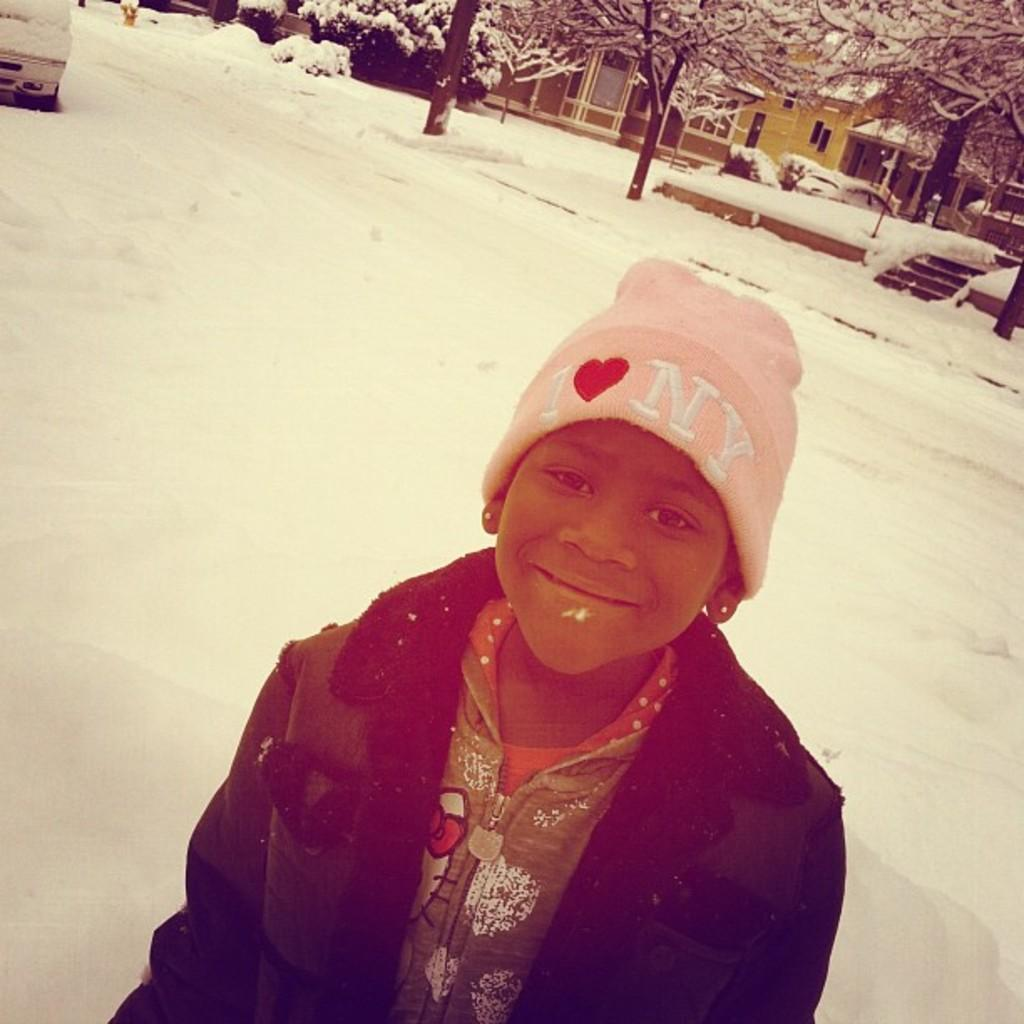What can be seen in the image? There is a person in the image. What is the person wearing on their head? The person is wearing a pink cap. What is the person wearing on their body? The person is wearing a green dress and jacket. Where is the person standing? The person is standing on the snow. What can be seen in the background of the image? There is a car, buildings, trees, and snow visible in the background of the image. What type of skin is visible on the person's lips in the image? There is no visible skin on the person's lips in the image, as the person is wearing a pink cap that covers their head. 